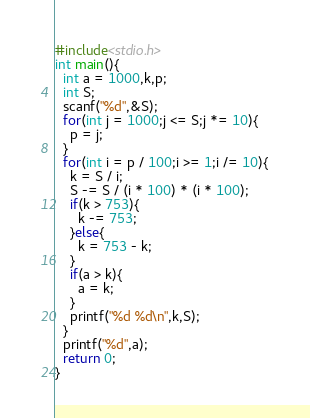<code> <loc_0><loc_0><loc_500><loc_500><_C_>#include<stdio.h>
int main(){
  int a = 1000,k,p;
  int S;
  scanf("%d",&S);
  for(int j = 1000;j <= S;j *= 10){
    p = j;
  }
  for(int i = p / 100;i >= 1;i /= 10){
    k = S / i;
    S -= S / (i * 100) * (i * 100);
    if(k > 753){
      k -= 753;
    }else{
      k = 753 - k;
    }
    if(a > k){
      a = k;
    }
    printf("%d %d\n",k,S);
  }
  printf("%d",a);
  return 0;
}</code> 